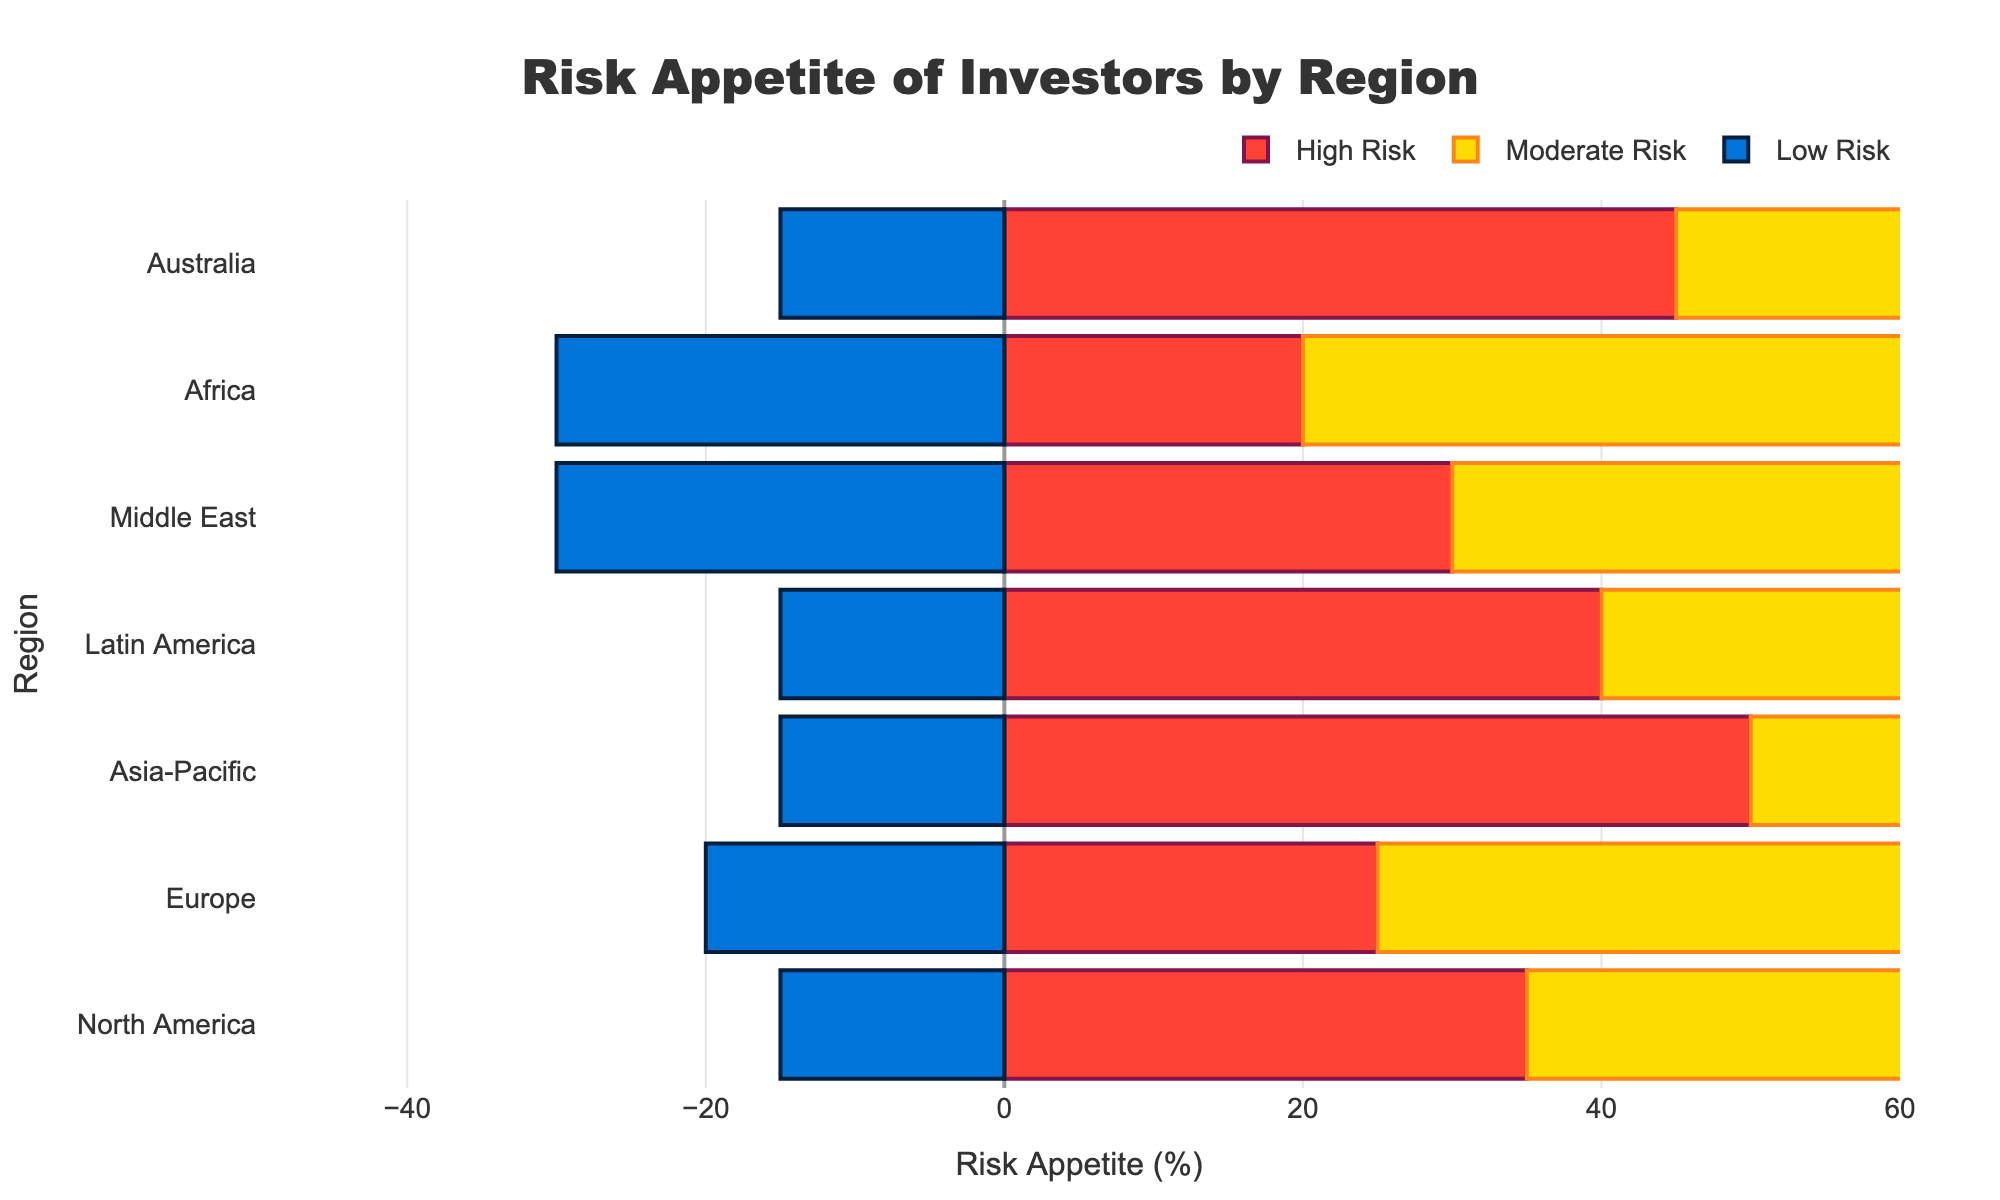Which region has the highest proportion of high risk appetite investors? By observing the largest bar segment in the red color representing high risk appetite investors, Asia-Pacific region has the highest proportion with 50%.
Answer: Asia-Pacific How many regions have a low risk appetite percentage of exactly 15%? Counting the bar segments in blue representing low risk appetite investors, North America, Asia-Pacific, Latin America, and Australia each have exactly 15%. Therefore, the total number of such regions is 4.
Answer: 4 What is the difference in percentage of investors with low risk appetite between Europe and the Middle East? Europe has 20% low risk appetite investors, and the Middle East has 30%. The difference is 30% - 20% = 10%.
Answer: 10% In which region is the proportion of moderate risk appetite investors the highest? The yellow bar segments representing moderate risk appetite investors are the largest in Europe, which has a moderate risk appetite percentage of 55%.
Answer: Europe What is the combined percentage of high and low risk appetite investors in North America? North America has 35% high risk appetite and 15% low risk appetite investors. Combining these gives 35% + 15% = 50%.
Answer: 50% Which region has the smallest segment for low risk appetite investors? The smallest blue bar segment representing low risk appetite investors is visually identified in the North America region with 15%.
Answer: North America How many regions have more than 40% moderate risk appetite investors? By examining the yellow bar segments, North America (50%), Europe (55%), Latin America (45%), and Africa (50%) have more than 40% moderate risk appetite investors. Therefore, there are 4 regions.
Answer: 4 Between which two regions is the difference in high risk appetite investors the largest? Comparing the lengths of the red bar segments, Asia-Pacific has 50% and Africa has 20%. The difference between them is 50% - 20% = 30%, which is the largest difference among all regions.
Answer: Asia-Pacific and Africa In which regions do high risk appetite investors outnumber low risk appetite investors? High risk appetite investors exceed low risk appetite investors in North America (35% vs 15%), Asia-Pacific (50% vs 15%), Latin America (40% vs 15%), and Australia (45% vs 15%).
Answer: North America, Asia-Pacific, Latin America, Australia 